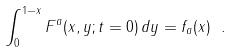<formula> <loc_0><loc_0><loc_500><loc_500>\int _ { 0 } ^ { 1 - x } F ^ { a } ( x , y ; t = 0 ) \, d y = f _ { a } ( x ) \ .</formula> 